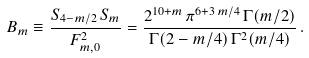<formula> <loc_0><loc_0><loc_500><loc_500>B _ { m } \equiv \frac { S _ { 4 - { m / 2 } } \, S _ { m } } { F _ { m , 0 } ^ { 2 } } = { \frac { { 2 ^ { 1 0 + m } } \, { { \pi } ^ { 6 + { { 3 \, m } / { 4 } } } } \, \Gamma ( { { m } / { 2 } } ) } { \Gamma ( 2 - { m } / { 4 } ) \, { { \Gamma ^ { 2 } ( { m } / { 4 } } ) } } } \, .</formula> 